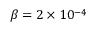<formula> <loc_0><loc_0><loc_500><loc_500>\beta = 2 \times 1 0 ^ { - 4 }</formula> 